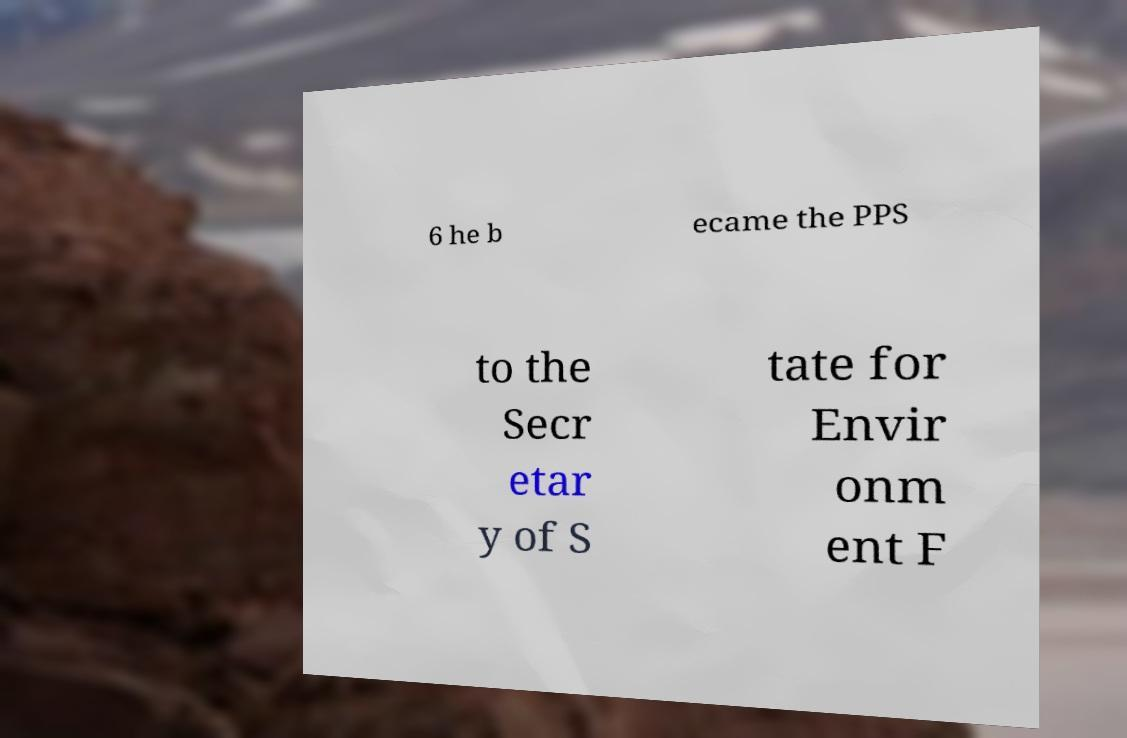Could you extract and type out the text from this image? 6 he b ecame the PPS to the Secr etar y of S tate for Envir onm ent F 